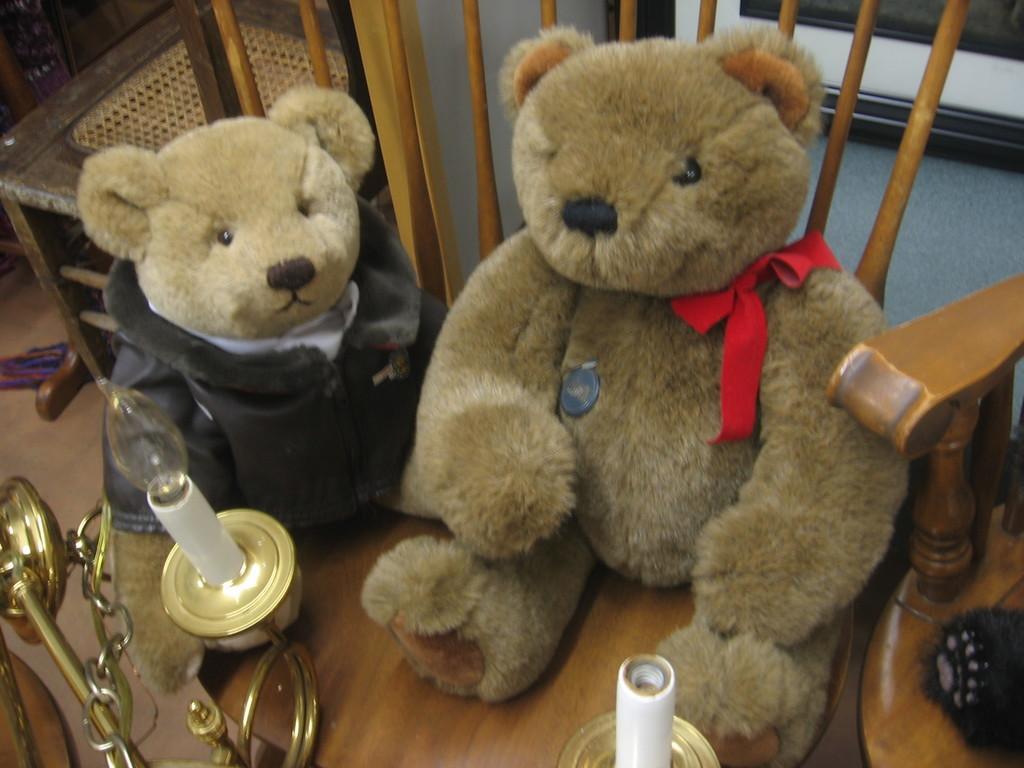Can you describe this image briefly? In the image there are two teddy bears kept on the floor and there are some objects kept in front of those teddy bears, on the either side of the teddy bears there are wooden chairs and in the background there is a wall and there is a frame attached to the wall. 